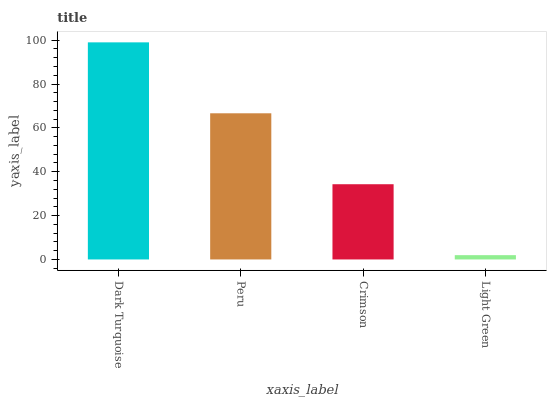Is Light Green the minimum?
Answer yes or no. Yes. Is Dark Turquoise the maximum?
Answer yes or no. Yes. Is Peru the minimum?
Answer yes or no. No. Is Peru the maximum?
Answer yes or no. No. Is Dark Turquoise greater than Peru?
Answer yes or no. Yes. Is Peru less than Dark Turquoise?
Answer yes or no. Yes. Is Peru greater than Dark Turquoise?
Answer yes or no. No. Is Dark Turquoise less than Peru?
Answer yes or no. No. Is Peru the high median?
Answer yes or no. Yes. Is Crimson the low median?
Answer yes or no. Yes. Is Light Green the high median?
Answer yes or no. No. Is Peru the low median?
Answer yes or no. No. 